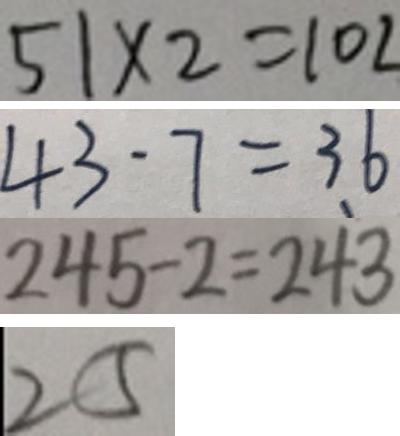Convert formula to latex. <formula><loc_0><loc_0><loc_500><loc_500>5 1 \times 2 = 1 0 2 
 4 3 - 7 = 3 6 
 2 4 5 - 2 = 2 4 3 
 2 5</formula> 